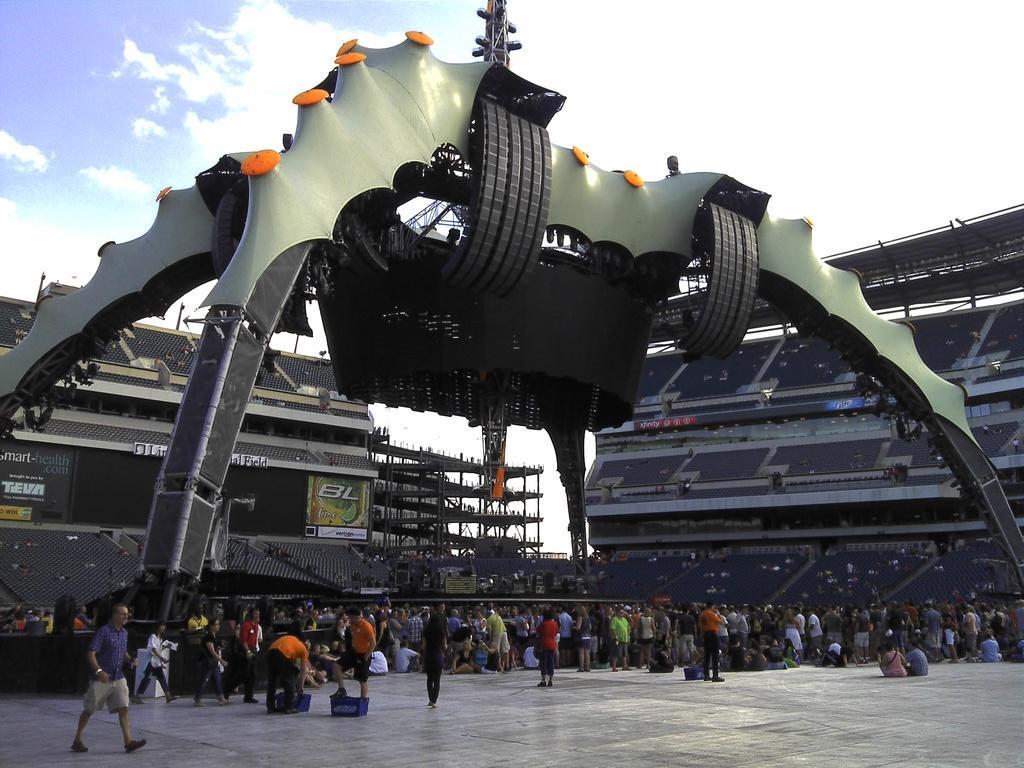How would you summarize this image in a sentence or two? In this image in the center there are persons standing and sitting. In the background there are chairs, stands. On the top there is a stand and the sky is cloudy. 